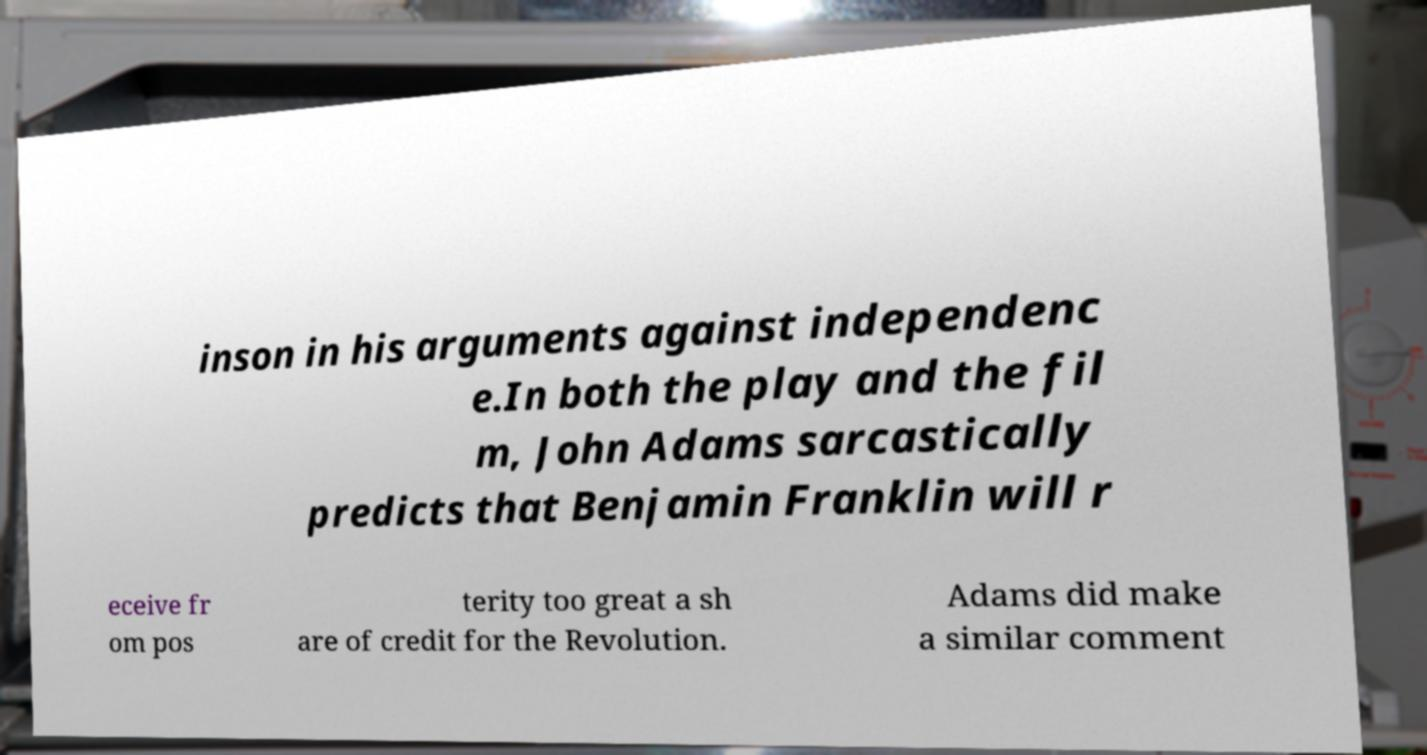Can you accurately transcribe the text from the provided image for me? inson in his arguments against independenc e.In both the play and the fil m, John Adams sarcastically predicts that Benjamin Franklin will r eceive fr om pos terity too great a sh are of credit for the Revolution. Adams did make a similar comment 